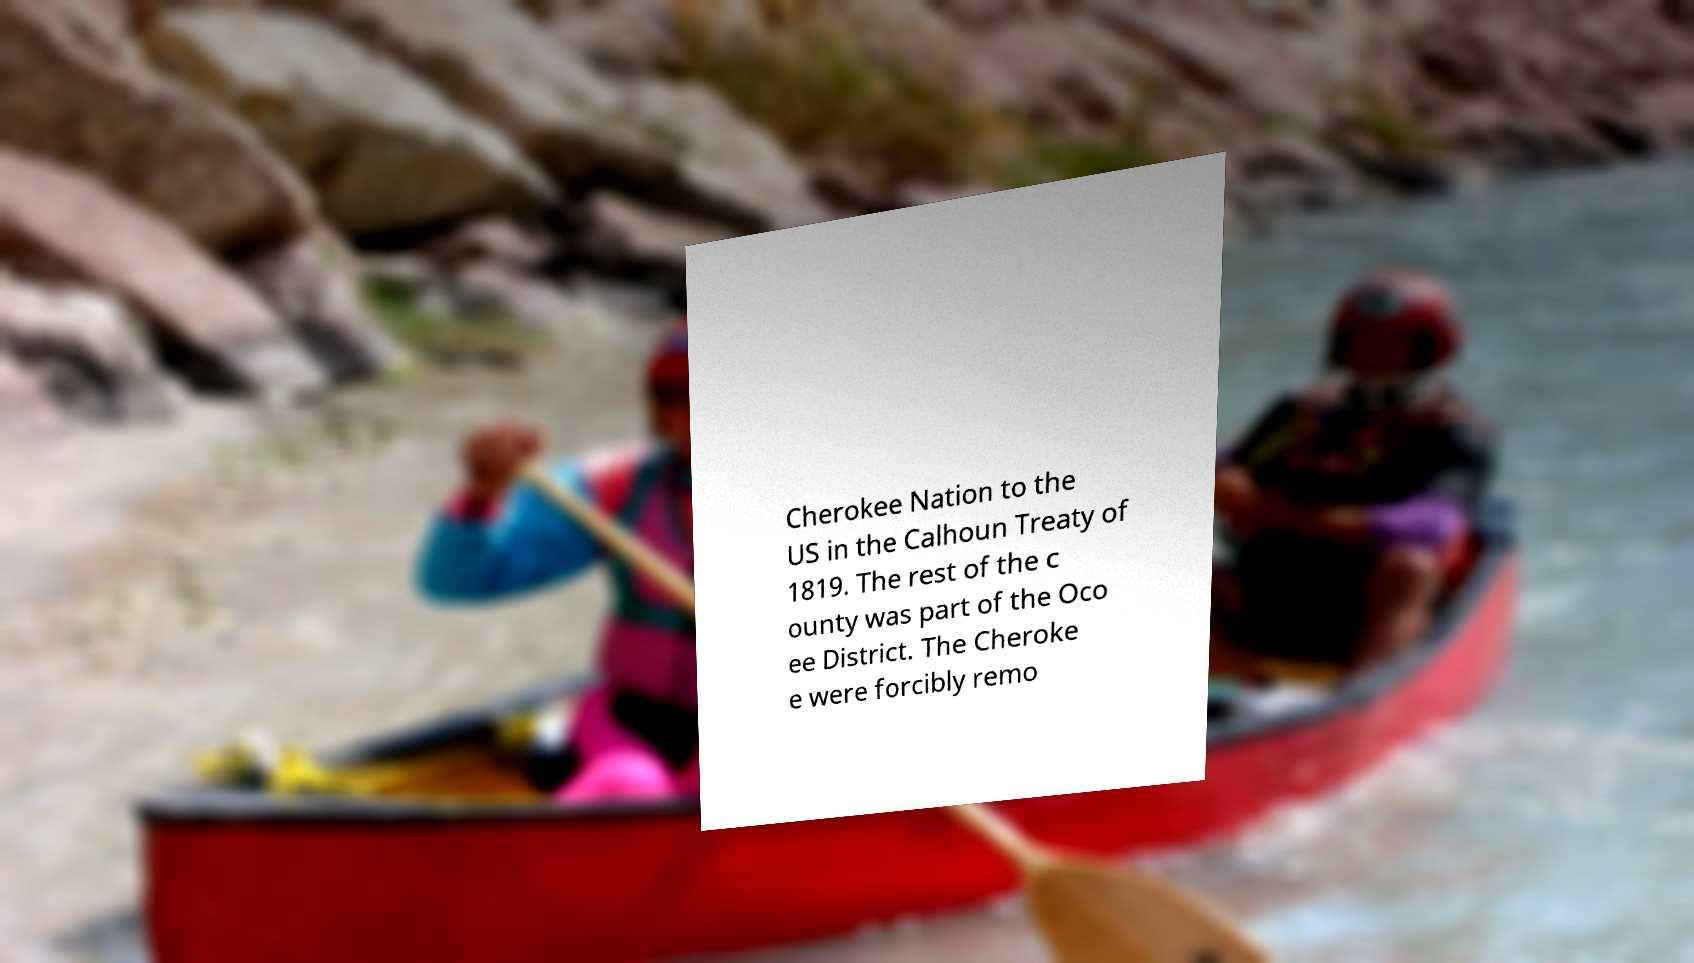There's text embedded in this image that I need extracted. Can you transcribe it verbatim? Cherokee Nation to the US in the Calhoun Treaty of 1819. The rest of the c ounty was part of the Oco ee District. The Cheroke e were forcibly remo 